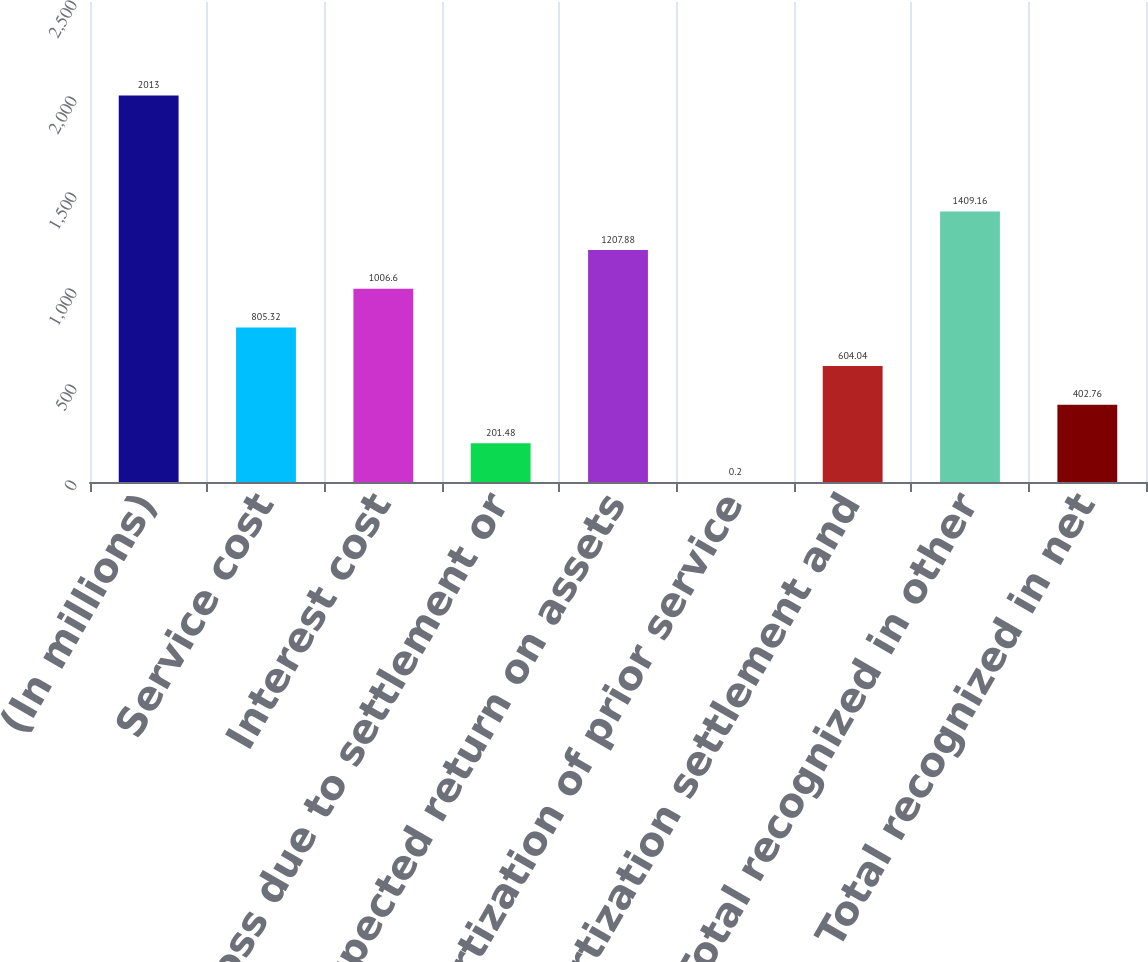Convert chart to OTSL. <chart><loc_0><loc_0><loc_500><loc_500><bar_chart><fcel>(In millions)<fcel>Service cost<fcel>Interest cost<fcel>Loss due to settlement or<fcel>Expected return on assets<fcel>Amortization of prior service<fcel>Amortization settlement and<fcel>Total recognized in other<fcel>Total recognized in net<nl><fcel>2013<fcel>805.32<fcel>1006.6<fcel>201.48<fcel>1207.88<fcel>0.2<fcel>604.04<fcel>1409.16<fcel>402.76<nl></chart> 